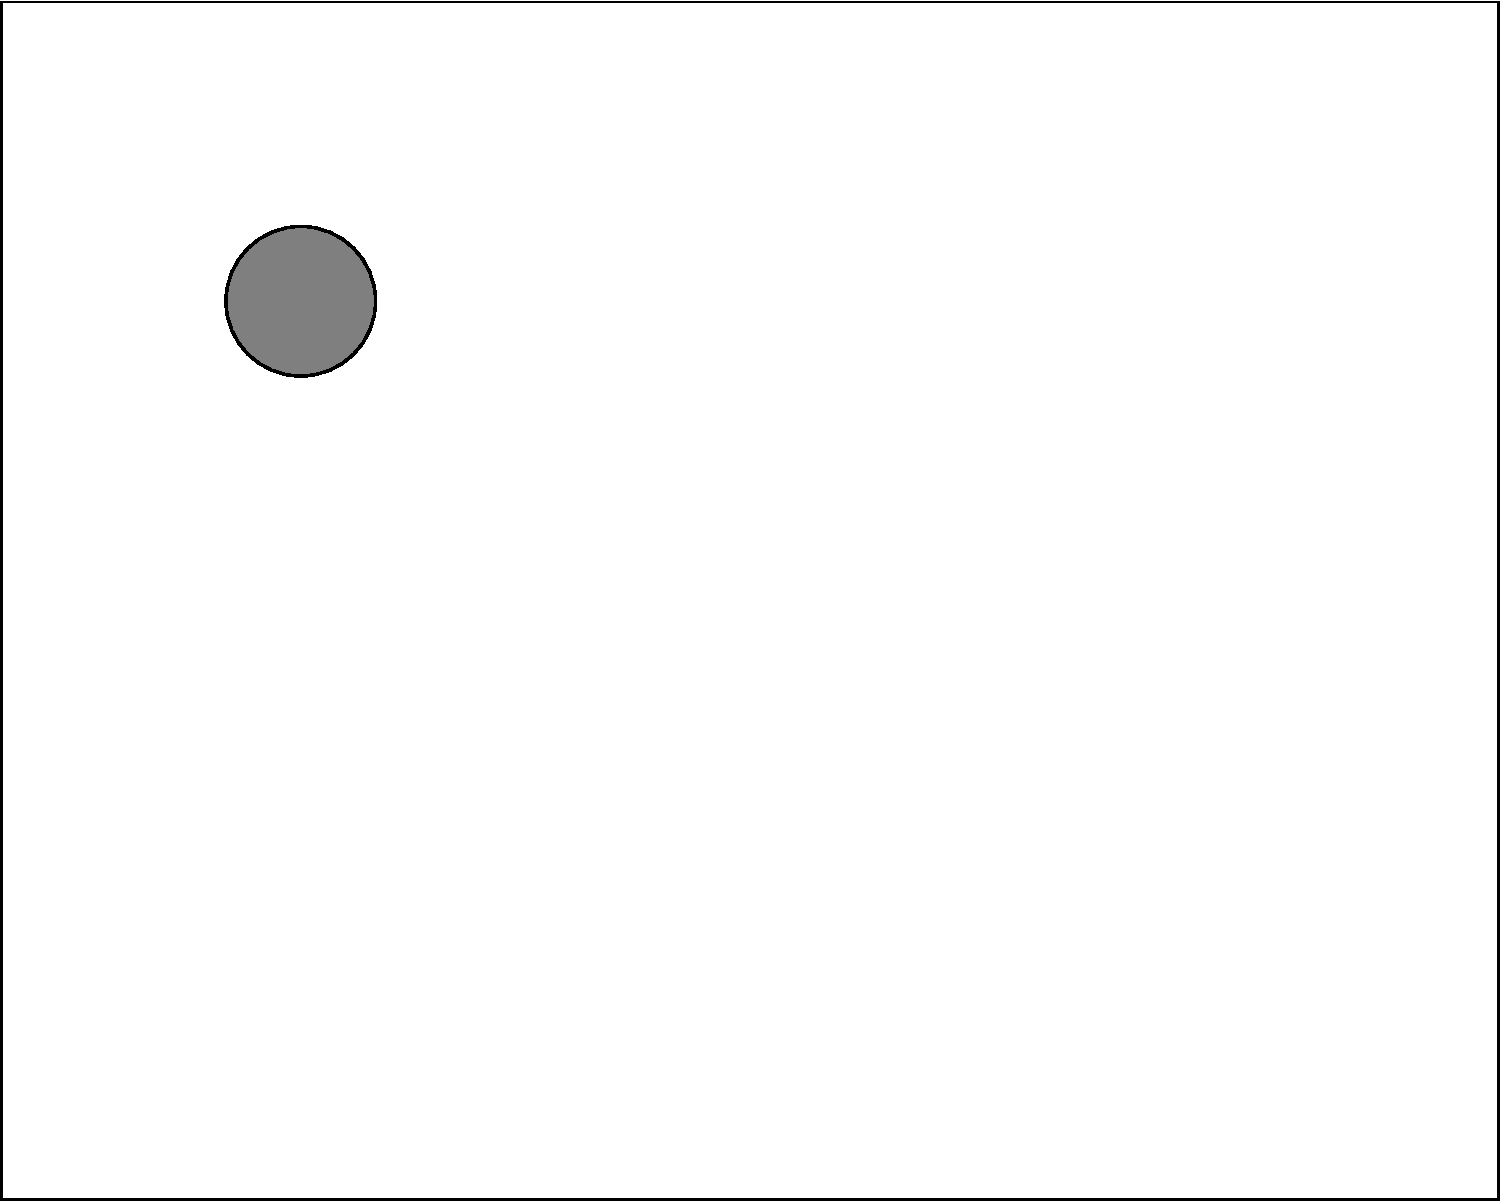In this kitchen layout, where would be the most efficient placement for a new refrigerator among options A, B, and C, considering traffic flow and proximity to existing fixtures? To determine the most efficient placement for the new refrigerator, we need to consider several factors:

1. Traffic flow: The refrigerator should not obstruct the main pathways in the kitchen.
2. Work triangle: The refrigerator should form an efficient work triangle with the sink and the primary food preparation area (counter).
3. Proximity to existing fixtures: It should be conveniently located near the sink and counter, but not too close to interfere with their use.
4. Door clearance: Ensure there's enough space for the refrigerator door to open fully.

Let's analyze each option:

A (3,4):
+ Good central location
+ Forms a reasonable work triangle with the sink and counter
- May obstruct traffic flow between the sink and counter

B (5,2):
+ Does not obstruct main traffic areas
+ Allows for door clearance
- Furthest from the sink, which is not ideal for the work triangle

C (7,5):
+ Does not obstruct main traffic areas
+ Allows for door clearance
+ Forms an efficient work triangle with the sink and counter
+ Close to the sink for convenience, but not too close to interfere

Based on these considerations, option C (7,5) provides the most efficient placement for the new refrigerator. It optimizes the work triangle, doesn't obstruct traffic flow, and maintains a good balance of proximity to existing fixtures.
Answer: C 